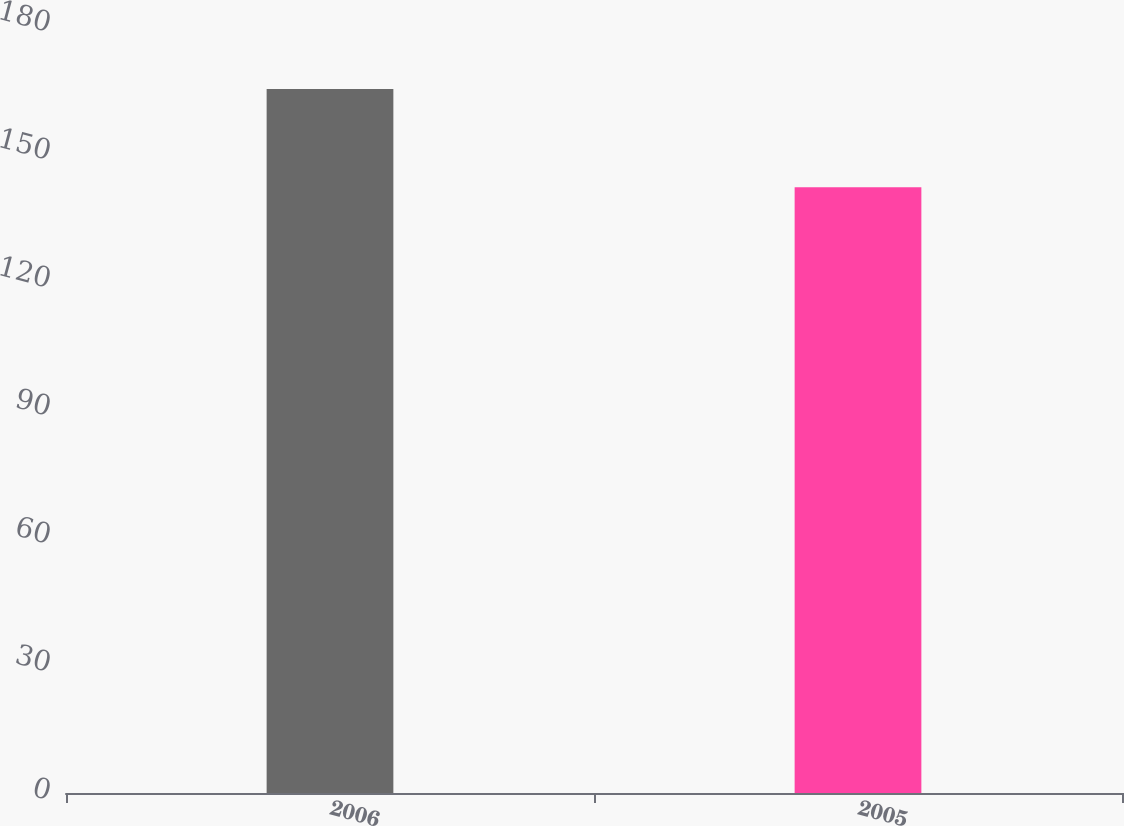Convert chart to OTSL. <chart><loc_0><loc_0><loc_500><loc_500><bar_chart><fcel>2006<fcel>2005<nl><fcel>165<fcel>142<nl></chart> 